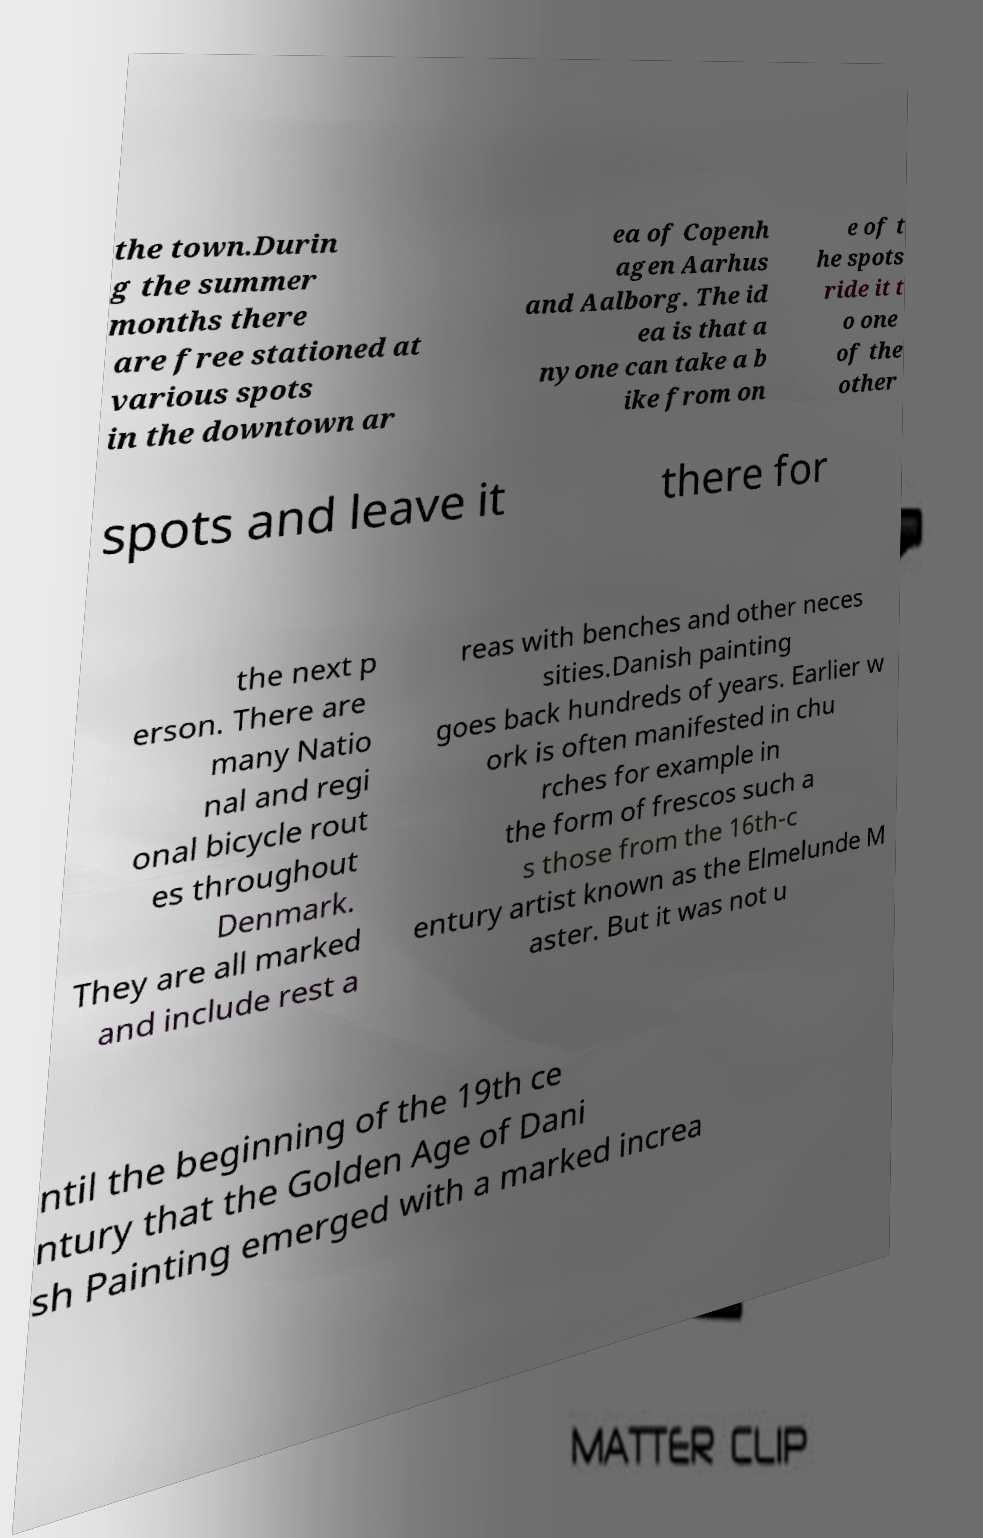Please read and relay the text visible in this image. What does it say? the town.Durin g the summer months there are free stationed at various spots in the downtown ar ea of Copenh agen Aarhus and Aalborg. The id ea is that a nyone can take a b ike from on e of t he spots ride it t o one of the other spots and leave it there for the next p erson. There are many Natio nal and regi onal bicycle rout es throughout Denmark. They are all marked and include rest a reas with benches and other neces sities.Danish painting goes back hundreds of years. Earlier w ork is often manifested in chu rches for example in the form of frescos such a s those from the 16th-c entury artist known as the Elmelunde M aster. But it was not u ntil the beginning of the 19th ce ntury that the Golden Age of Dani sh Painting emerged with a marked increa 